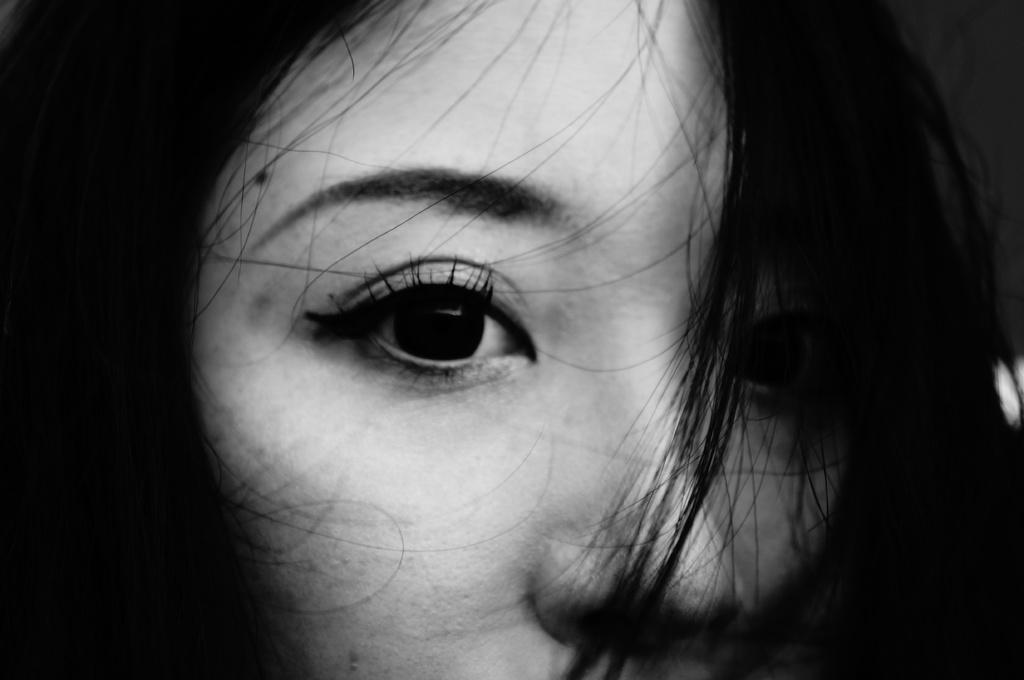Describe this image in one or two sentences. This is a black and white image of a person. 